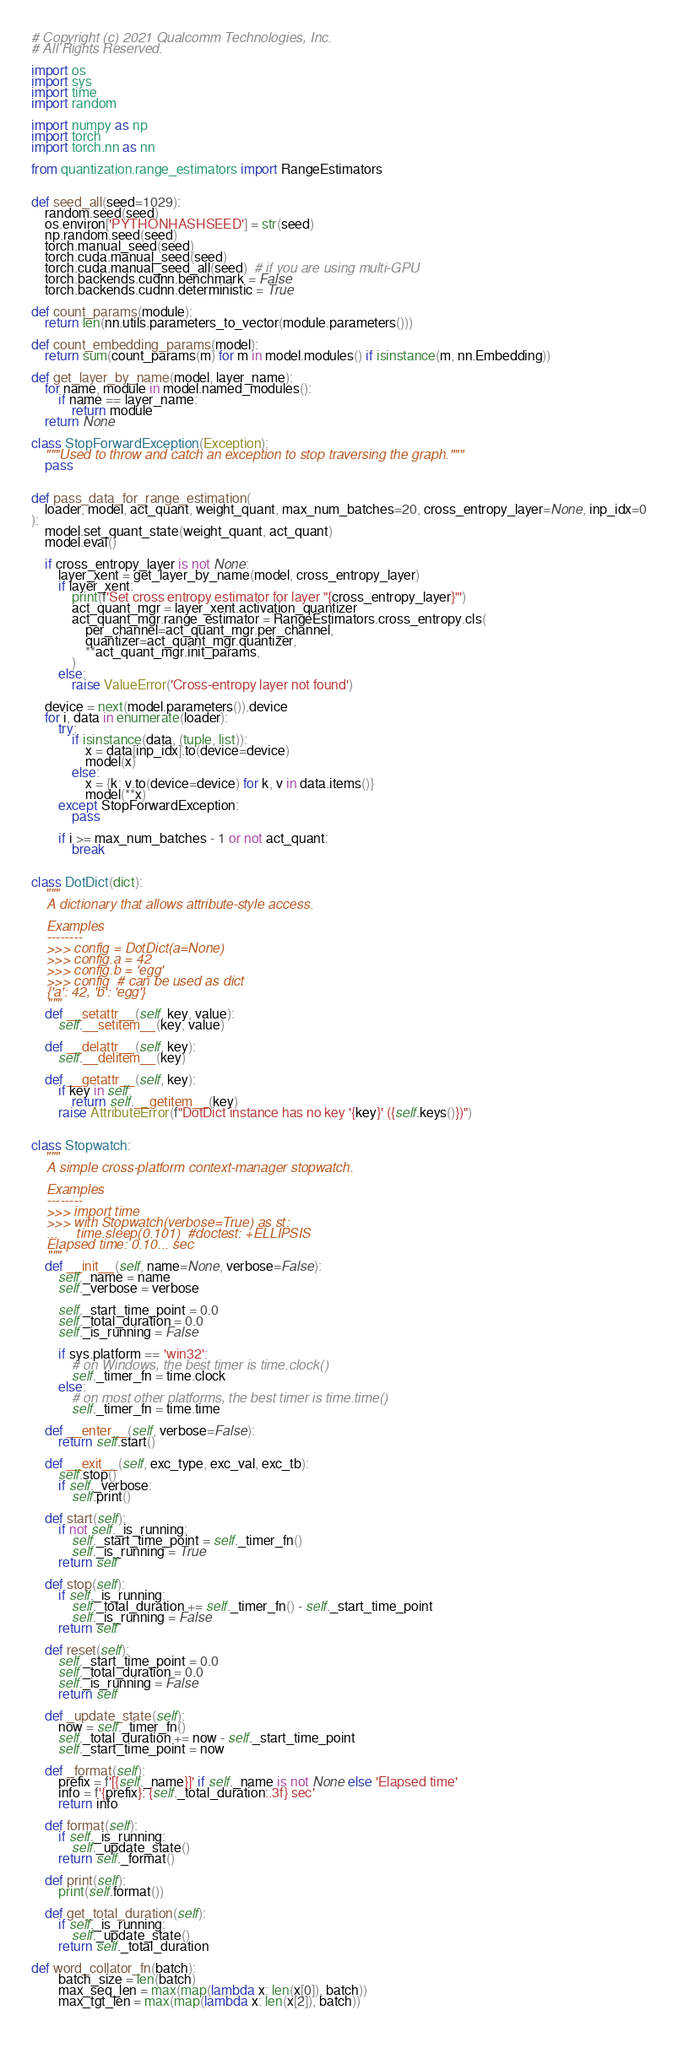<code> <loc_0><loc_0><loc_500><loc_500><_Python_># Copyright (c) 2021 Qualcomm Technologies, Inc.
# All Rights Reserved.

import os
import sys
import time
import random

import numpy as np
import torch
import torch.nn as nn

from quantization.range_estimators import RangeEstimators


def seed_all(seed=1029):
    random.seed(seed)
    os.environ['PYTHONHASHSEED'] = str(seed)
    np.random.seed(seed)
    torch.manual_seed(seed)
    torch.cuda.manual_seed(seed)
    torch.cuda.manual_seed_all(seed)  # if you are using multi-GPU
    torch.backends.cudnn.benchmark = False
    torch.backends.cudnn.deterministic = True

def count_params(module):
    return len(nn.utils.parameters_to_vector(module.parameters()))

def count_embedding_params(model):
    return sum(count_params(m) for m in model.modules() if isinstance(m, nn.Embedding))

def get_layer_by_name(model, layer_name):
    for name, module in model.named_modules():
        if name == layer_name:
            return module
    return None

class StopForwardException(Exception):
    """Used to throw and catch an exception to stop traversing the graph."""
    pass


def pass_data_for_range_estimation(
    loader, model, act_quant, weight_quant, max_num_batches=20, cross_entropy_layer=None, inp_idx=0
):
    model.set_quant_state(weight_quant, act_quant)
    model.eval()

    if cross_entropy_layer is not None:
        layer_xent = get_layer_by_name(model, cross_entropy_layer)
        if layer_xent:
            print(f'Set cross entropy estimator for layer "{cross_entropy_layer}"')
            act_quant_mgr = layer_xent.activation_quantizer
            act_quant_mgr.range_estimator = RangeEstimators.cross_entropy.cls(
                per_channel=act_quant_mgr.per_channel,
                quantizer=act_quant_mgr.quantizer,
                **act_quant_mgr.init_params,
            )
        else:
            raise ValueError('Cross-entropy layer not found')

    device = next(model.parameters()).device
    for i, data in enumerate(loader):
        try:
            if isinstance(data, (tuple, list)):
                x = data[inp_idx].to(device=device)
                model(x)
            else:
                x = {k: v.to(device=device) for k, v in data.items()}
                model(**x)
        except StopForwardException:
            pass

        if i >= max_num_batches - 1 or not act_quant:
            break


class DotDict(dict):
    """
    A dictionary that allows attribute-style access.

    Examples
    --------
    >>> config = DotDict(a=None)
    >>> config.a = 42
    >>> config.b = 'egg'
    >>> config  # can be used as dict
    {'a': 42, 'b': 'egg'}
    """
    def __setattr__(self, key, value):
        self.__setitem__(key, value)

    def __delattr__(self, key):
        self.__delitem__(key)

    def __getattr__(self, key):
        if key in self:
            return self.__getitem__(key)
        raise AttributeError(f"DotDict instance has no key '{key}' ({self.keys()})")


class Stopwatch:
    """
    A simple cross-platform context-manager stopwatch.

    Examples
    --------
    >>> import time
    >>> with Stopwatch(verbose=True) as st:
    ...     time.sleep(0.101)  #doctest: +ELLIPSIS
    Elapsed time: 0.10... sec
    """
    def __init__(self, name=None, verbose=False):
        self._name = name
        self._verbose = verbose

        self._start_time_point = 0.0
        self._total_duration = 0.0
        self._is_running = False

        if sys.platform == 'win32':
            # on Windows, the best timer is time.clock()
            self._timer_fn = time.clock
        else:
            # on most other platforms, the best timer is time.time()
            self._timer_fn = time.time

    def __enter__(self, verbose=False):
        return self.start()

    def __exit__(self, exc_type, exc_val, exc_tb):
        self.stop()
        if self._verbose:
            self.print()

    def start(self):
        if not self._is_running:
            self._start_time_point = self._timer_fn()
            self._is_running = True
        return self

    def stop(self):
        if self._is_running:
            self._total_duration += self._timer_fn() - self._start_time_point
            self._is_running = False
        return self

    def reset(self):
        self._start_time_point = 0.0
        self._total_duration = 0.0
        self._is_running = False
        return self

    def _update_state(self):
        now = self._timer_fn()
        self._total_duration += now - self._start_time_point
        self._start_time_point = now

    def _format(self):
        prefix = f'[{self._name}]' if self._name is not None else 'Elapsed time'
        info = f'{prefix}: {self._total_duration:.3f} sec'
        return info

    def format(self):
        if self._is_running:
            self._update_state()
        return self._format()

    def print(self):
        print(self.format())

    def get_total_duration(self):
        if self._is_running:
            self._update_state()
        return self._total_duration

def word_collator_fn(batch):
        batch_size = len(batch)
        max_seq_len = max(map(lambda x: len(x[0]), batch))
        max_tgt_len = max(map(lambda x: len(x[2]), batch))
        </code> 